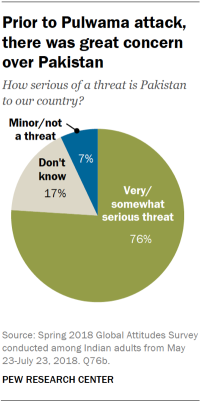Draw attention to some important aspects in this diagram. Find the percentage whose value occupied most in the pie chart, which is 0.76. The green and blue segments in the pie chart add up to a ratio of approximately 1.0857, indicating that the two segments make up approximately 1.0857 units of the pie chart. 